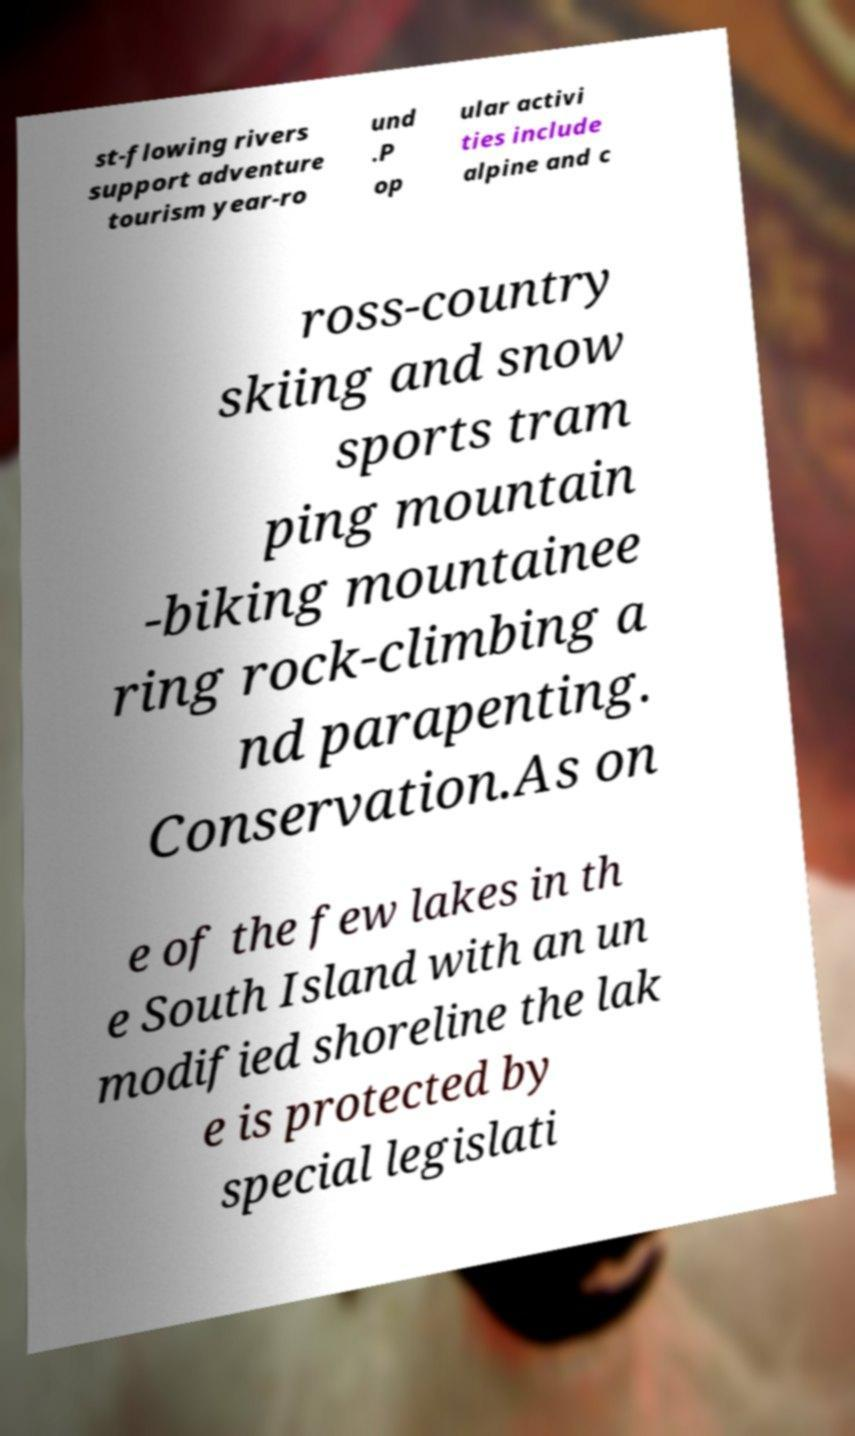Could you assist in decoding the text presented in this image and type it out clearly? st-flowing rivers support adventure tourism year-ro und .P op ular activi ties include alpine and c ross-country skiing and snow sports tram ping mountain -biking mountainee ring rock-climbing a nd parapenting. Conservation.As on e of the few lakes in th e South Island with an un modified shoreline the lak e is protected by special legislati 